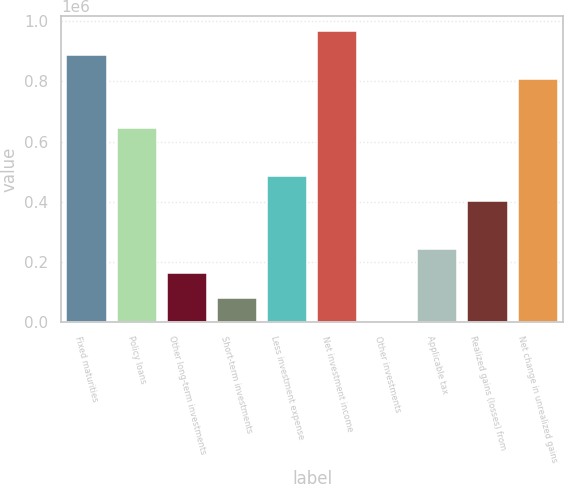Convert chart to OTSL. <chart><loc_0><loc_0><loc_500><loc_500><bar_chart><fcel>Fixed maturities<fcel>Policy loans<fcel>Other long-term investments<fcel>Short-term investments<fcel>Less investment expense<fcel>Net investment income<fcel>Other investments<fcel>Applicable tax<fcel>Realized gains (losses) from<fcel>Net change in unrealized gains<nl><fcel>887590<fcel>645530<fcel>161411<fcel>80724.5<fcel>484157<fcel>968276<fcel>38<fcel>242098<fcel>403470<fcel>806903<nl></chart> 